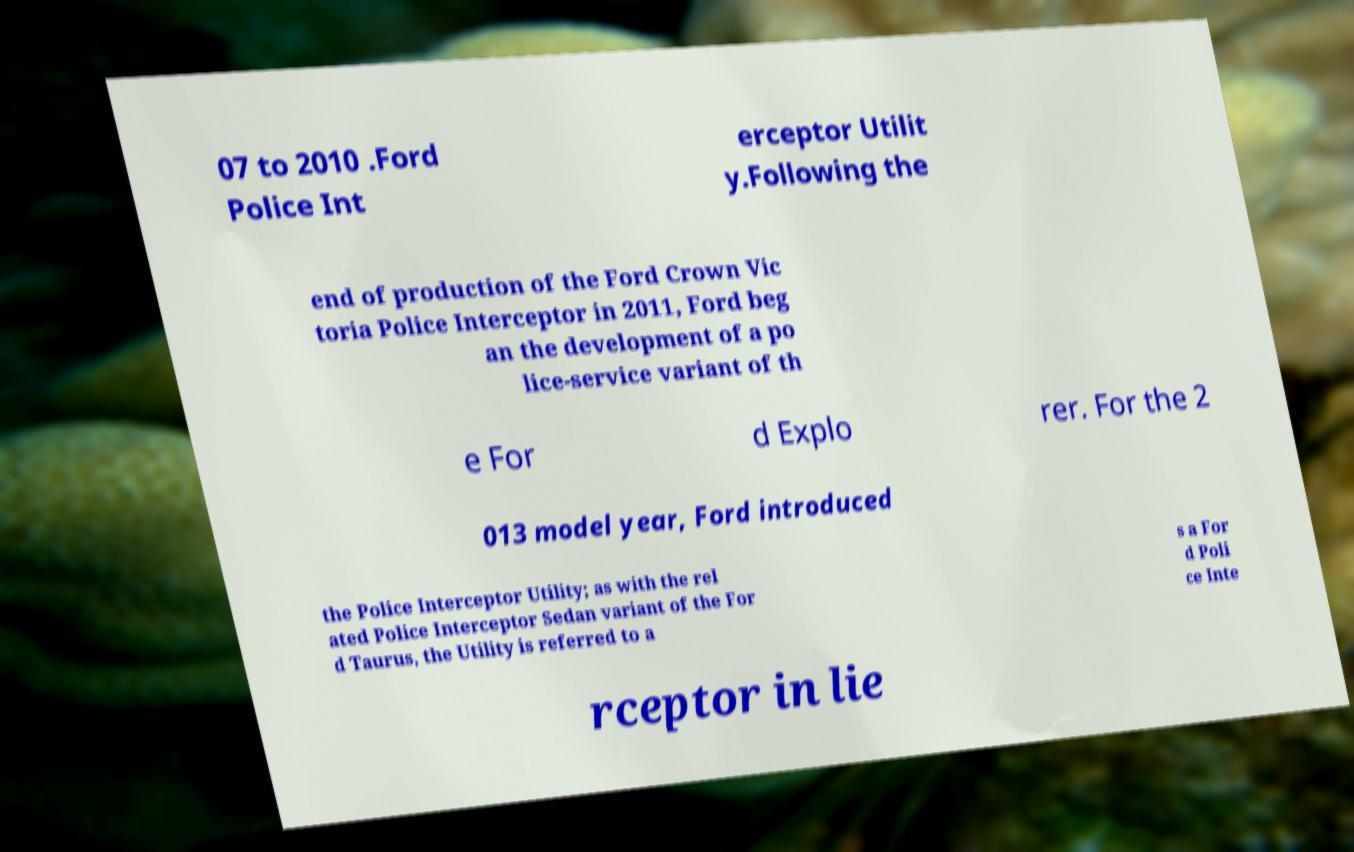There's text embedded in this image that I need extracted. Can you transcribe it verbatim? 07 to 2010 .Ford Police Int erceptor Utilit y.Following the end of production of the Ford Crown Vic toria Police Interceptor in 2011, Ford beg an the development of a po lice-service variant of th e For d Explo rer. For the 2 013 model year, Ford introduced the Police Interceptor Utility; as with the rel ated Police Interceptor Sedan variant of the For d Taurus, the Utility is referred to a s a For d Poli ce Inte rceptor in lie 